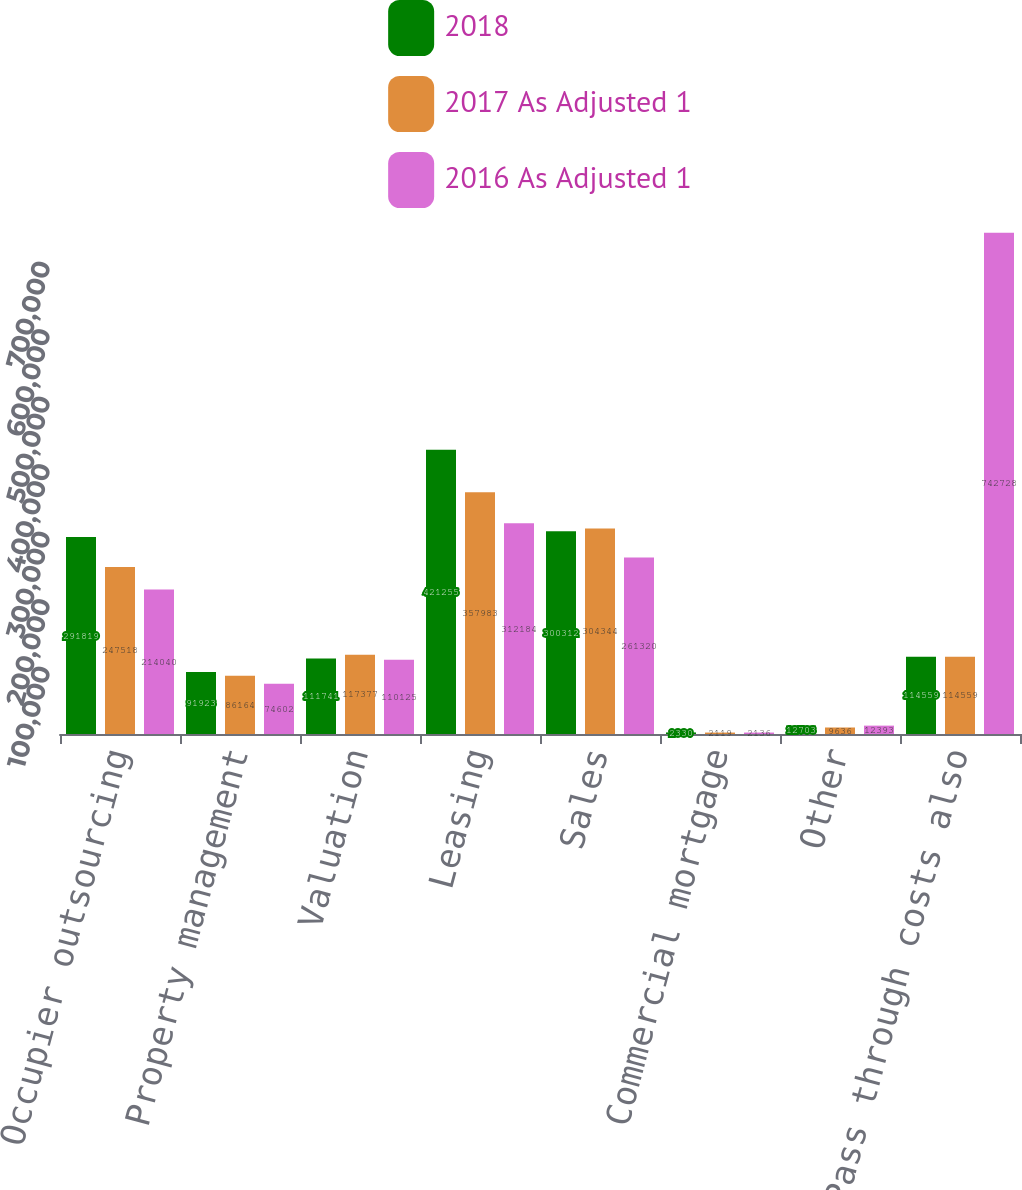Convert chart to OTSL. <chart><loc_0><loc_0><loc_500><loc_500><stacked_bar_chart><ecel><fcel>Occupier outsourcing<fcel>Property management<fcel>Valuation<fcel>Leasing<fcel>Sales<fcel>Commercial mortgage<fcel>Other<fcel>Pass through costs also<nl><fcel>2018<fcel>291819<fcel>91923<fcel>111741<fcel>421255<fcel>300312<fcel>2330<fcel>12703<fcel>114559<nl><fcel>2017 As Adjusted 1<fcel>247518<fcel>86164<fcel>117377<fcel>357983<fcel>304344<fcel>2119<fcel>9636<fcel>114559<nl><fcel>2016 As Adjusted 1<fcel>214040<fcel>74602<fcel>110125<fcel>312184<fcel>261320<fcel>2136<fcel>12393<fcel>742728<nl></chart> 